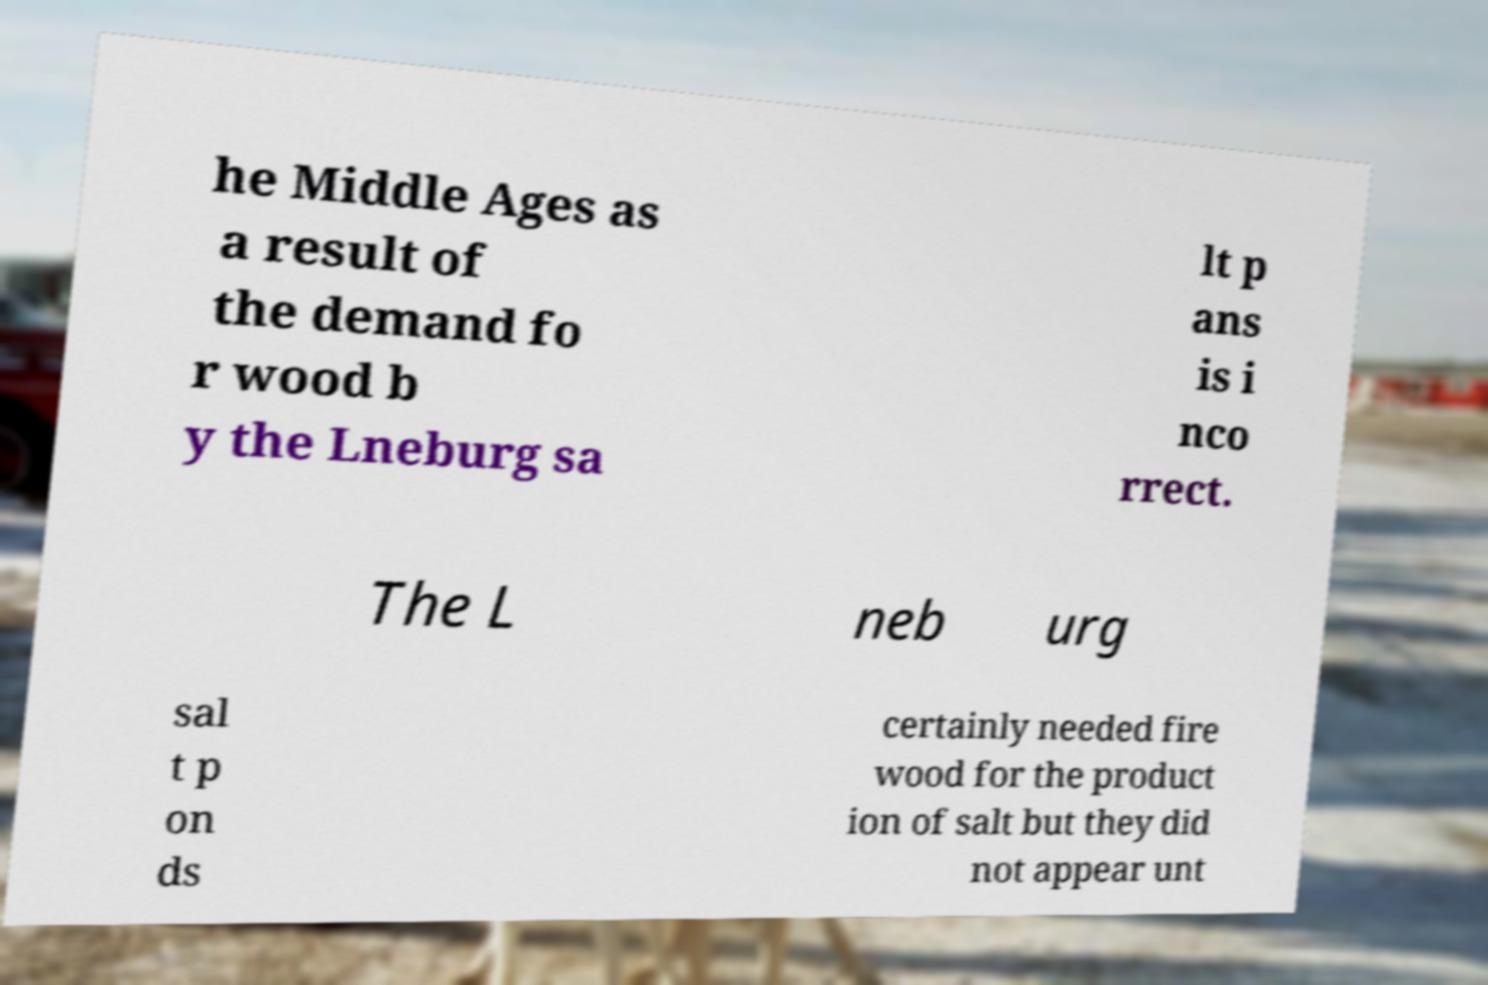I need the written content from this picture converted into text. Can you do that? he Middle Ages as a result of the demand fo r wood b y the Lneburg sa lt p ans is i nco rrect. The L neb urg sal t p on ds certainly needed fire wood for the product ion of salt but they did not appear unt 